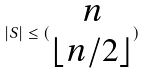<formula> <loc_0><loc_0><loc_500><loc_500>| S | \leq ( \begin{matrix} n \\ \lfloor n / 2 \rfloor \end{matrix} )</formula> 